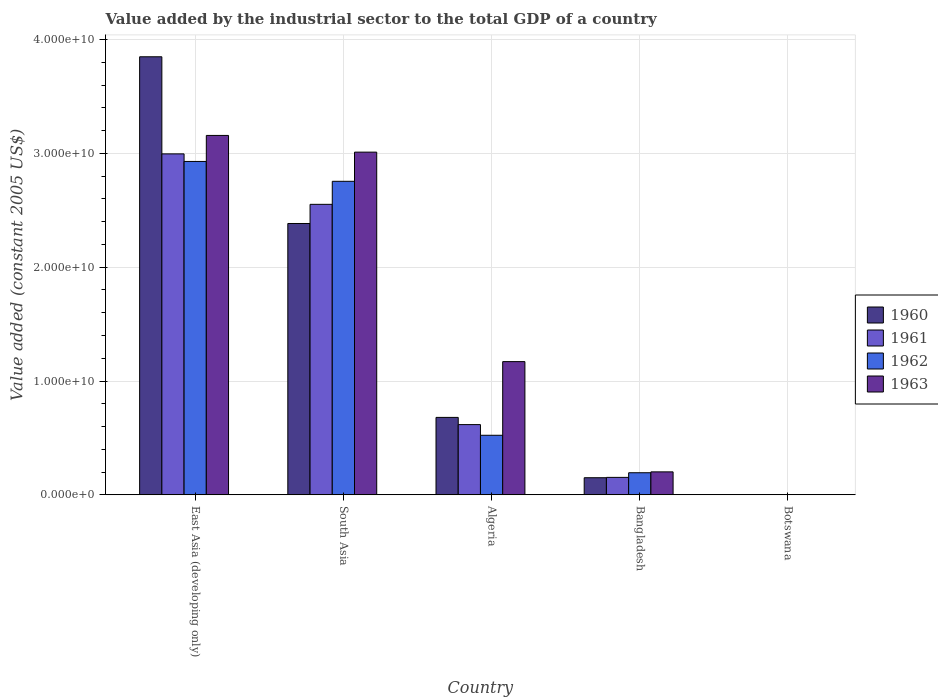How many groups of bars are there?
Your answer should be compact. 5. Are the number of bars per tick equal to the number of legend labels?
Provide a short and direct response. Yes. What is the label of the 2nd group of bars from the left?
Provide a short and direct response. South Asia. In how many cases, is the number of bars for a given country not equal to the number of legend labels?
Make the answer very short. 0. What is the value added by the industrial sector in 1963 in South Asia?
Make the answer very short. 3.01e+1. Across all countries, what is the maximum value added by the industrial sector in 1962?
Offer a very short reply. 2.93e+1. Across all countries, what is the minimum value added by the industrial sector in 1961?
Make the answer very short. 1.92e+07. In which country was the value added by the industrial sector in 1962 maximum?
Keep it short and to the point. East Asia (developing only). In which country was the value added by the industrial sector in 1960 minimum?
Offer a very short reply. Botswana. What is the total value added by the industrial sector in 1962 in the graph?
Offer a terse response. 6.40e+1. What is the difference between the value added by the industrial sector in 1962 in Algeria and that in Bangladesh?
Offer a very short reply. 3.29e+09. What is the difference between the value added by the industrial sector in 1960 in South Asia and the value added by the industrial sector in 1963 in Bangladesh?
Give a very brief answer. 2.18e+1. What is the average value added by the industrial sector in 1961 per country?
Your answer should be compact. 1.26e+1. What is the difference between the value added by the industrial sector of/in 1962 and value added by the industrial sector of/in 1961 in Algeria?
Ensure brevity in your answer.  -9.37e+08. What is the ratio of the value added by the industrial sector in 1962 in Botswana to that in South Asia?
Provide a succinct answer. 0. Is the value added by the industrial sector in 1960 in Botswana less than that in South Asia?
Give a very brief answer. Yes. Is the difference between the value added by the industrial sector in 1962 in Bangladesh and Botswana greater than the difference between the value added by the industrial sector in 1961 in Bangladesh and Botswana?
Give a very brief answer. Yes. What is the difference between the highest and the second highest value added by the industrial sector in 1961?
Your answer should be compact. -2.38e+1. What is the difference between the highest and the lowest value added by the industrial sector in 1960?
Your answer should be compact. 3.85e+1. Is the sum of the value added by the industrial sector in 1962 in Bangladesh and Botswana greater than the maximum value added by the industrial sector in 1963 across all countries?
Offer a terse response. No. Is it the case that in every country, the sum of the value added by the industrial sector in 1961 and value added by the industrial sector in 1960 is greater than the value added by the industrial sector in 1963?
Make the answer very short. Yes. What is the difference between two consecutive major ticks on the Y-axis?
Keep it short and to the point. 1.00e+1. Are the values on the major ticks of Y-axis written in scientific E-notation?
Offer a very short reply. Yes. Does the graph contain any zero values?
Give a very brief answer. No. What is the title of the graph?
Offer a terse response. Value added by the industrial sector to the total GDP of a country. What is the label or title of the Y-axis?
Your answer should be very brief. Value added (constant 2005 US$). What is the Value added (constant 2005 US$) in 1960 in East Asia (developing only)?
Make the answer very short. 3.85e+1. What is the Value added (constant 2005 US$) in 1961 in East Asia (developing only)?
Keep it short and to the point. 3.00e+1. What is the Value added (constant 2005 US$) of 1962 in East Asia (developing only)?
Ensure brevity in your answer.  2.93e+1. What is the Value added (constant 2005 US$) in 1963 in East Asia (developing only)?
Your response must be concise. 3.16e+1. What is the Value added (constant 2005 US$) in 1960 in South Asia?
Your answer should be very brief. 2.38e+1. What is the Value added (constant 2005 US$) of 1961 in South Asia?
Your answer should be compact. 2.55e+1. What is the Value added (constant 2005 US$) of 1962 in South Asia?
Provide a short and direct response. 2.76e+1. What is the Value added (constant 2005 US$) of 1963 in South Asia?
Keep it short and to the point. 3.01e+1. What is the Value added (constant 2005 US$) of 1960 in Algeria?
Make the answer very short. 6.80e+09. What is the Value added (constant 2005 US$) of 1961 in Algeria?
Your answer should be very brief. 6.17e+09. What is the Value added (constant 2005 US$) in 1962 in Algeria?
Your response must be concise. 5.23e+09. What is the Value added (constant 2005 US$) in 1963 in Algeria?
Provide a succinct answer. 1.17e+1. What is the Value added (constant 2005 US$) of 1960 in Bangladesh?
Make the answer very short. 1.50e+09. What is the Value added (constant 2005 US$) in 1961 in Bangladesh?
Your response must be concise. 1.53e+09. What is the Value added (constant 2005 US$) of 1962 in Bangladesh?
Provide a succinct answer. 1.94e+09. What is the Value added (constant 2005 US$) in 1963 in Bangladesh?
Keep it short and to the point. 2.01e+09. What is the Value added (constant 2005 US$) in 1960 in Botswana?
Your answer should be very brief. 1.96e+07. What is the Value added (constant 2005 US$) in 1961 in Botswana?
Offer a terse response. 1.92e+07. What is the Value added (constant 2005 US$) in 1962 in Botswana?
Your response must be concise. 1.98e+07. What is the Value added (constant 2005 US$) of 1963 in Botswana?
Provide a succinct answer. 1.83e+07. Across all countries, what is the maximum Value added (constant 2005 US$) of 1960?
Offer a very short reply. 3.85e+1. Across all countries, what is the maximum Value added (constant 2005 US$) in 1961?
Offer a terse response. 3.00e+1. Across all countries, what is the maximum Value added (constant 2005 US$) of 1962?
Provide a short and direct response. 2.93e+1. Across all countries, what is the maximum Value added (constant 2005 US$) of 1963?
Provide a succinct answer. 3.16e+1. Across all countries, what is the minimum Value added (constant 2005 US$) in 1960?
Make the answer very short. 1.96e+07. Across all countries, what is the minimum Value added (constant 2005 US$) in 1961?
Provide a succinct answer. 1.92e+07. Across all countries, what is the minimum Value added (constant 2005 US$) of 1962?
Make the answer very short. 1.98e+07. Across all countries, what is the minimum Value added (constant 2005 US$) in 1963?
Provide a short and direct response. 1.83e+07. What is the total Value added (constant 2005 US$) of 1960 in the graph?
Provide a succinct answer. 7.07e+1. What is the total Value added (constant 2005 US$) of 1961 in the graph?
Provide a succinct answer. 6.32e+1. What is the total Value added (constant 2005 US$) in 1962 in the graph?
Make the answer very short. 6.40e+1. What is the total Value added (constant 2005 US$) of 1963 in the graph?
Provide a short and direct response. 7.54e+1. What is the difference between the Value added (constant 2005 US$) of 1960 in East Asia (developing only) and that in South Asia?
Ensure brevity in your answer.  1.47e+1. What is the difference between the Value added (constant 2005 US$) of 1961 in East Asia (developing only) and that in South Asia?
Provide a short and direct response. 4.43e+09. What is the difference between the Value added (constant 2005 US$) of 1962 in East Asia (developing only) and that in South Asia?
Make the answer very short. 1.74e+09. What is the difference between the Value added (constant 2005 US$) in 1963 in East Asia (developing only) and that in South Asia?
Your answer should be compact. 1.47e+09. What is the difference between the Value added (constant 2005 US$) of 1960 in East Asia (developing only) and that in Algeria?
Offer a very short reply. 3.17e+1. What is the difference between the Value added (constant 2005 US$) of 1961 in East Asia (developing only) and that in Algeria?
Provide a short and direct response. 2.38e+1. What is the difference between the Value added (constant 2005 US$) of 1962 in East Asia (developing only) and that in Algeria?
Your answer should be compact. 2.41e+1. What is the difference between the Value added (constant 2005 US$) of 1963 in East Asia (developing only) and that in Algeria?
Your response must be concise. 1.99e+1. What is the difference between the Value added (constant 2005 US$) of 1960 in East Asia (developing only) and that in Bangladesh?
Give a very brief answer. 3.70e+1. What is the difference between the Value added (constant 2005 US$) of 1961 in East Asia (developing only) and that in Bangladesh?
Offer a very short reply. 2.84e+1. What is the difference between the Value added (constant 2005 US$) of 1962 in East Asia (developing only) and that in Bangladesh?
Offer a terse response. 2.74e+1. What is the difference between the Value added (constant 2005 US$) in 1963 in East Asia (developing only) and that in Bangladesh?
Provide a short and direct response. 2.96e+1. What is the difference between the Value added (constant 2005 US$) of 1960 in East Asia (developing only) and that in Botswana?
Offer a terse response. 3.85e+1. What is the difference between the Value added (constant 2005 US$) of 1961 in East Asia (developing only) and that in Botswana?
Offer a terse response. 2.99e+1. What is the difference between the Value added (constant 2005 US$) in 1962 in East Asia (developing only) and that in Botswana?
Offer a terse response. 2.93e+1. What is the difference between the Value added (constant 2005 US$) of 1963 in East Asia (developing only) and that in Botswana?
Your response must be concise. 3.16e+1. What is the difference between the Value added (constant 2005 US$) of 1960 in South Asia and that in Algeria?
Your answer should be very brief. 1.70e+1. What is the difference between the Value added (constant 2005 US$) of 1961 in South Asia and that in Algeria?
Your response must be concise. 1.94e+1. What is the difference between the Value added (constant 2005 US$) of 1962 in South Asia and that in Algeria?
Provide a succinct answer. 2.23e+1. What is the difference between the Value added (constant 2005 US$) in 1963 in South Asia and that in Algeria?
Provide a short and direct response. 1.84e+1. What is the difference between the Value added (constant 2005 US$) of 1960 in South Asia and that in Bangladesh?
Give a very brief answer. 2.23e+1. What is the difference between the Value added (constant 2005 US$) of 1961 in South Asia and that in Bangladesh?
Keep it short and to the point. 2.40e+1. What is the difference between the Value added (constant 2005 US$) in 1962 in South Asia and that in Bangladesh?
Provide a succinct answer. 2.56e+1. What is the difference between the Value added (constant 2005 US$) of 1963 in South Asia and that in Bangladesh?
Provide a short and direct response. 2.81e+1. What is the difference between the Value added (constant 2005 US$) of 1960 in South Asia and that in Botswana?
Give a very brief answer. 2.38e+1. What is the difference between the Value added (constant 2005 US$) in 1961 in South Asia and that in Botswana?
Your answer should be very brief. 2.55e+1. What is the difference between the Value added (constant 2005 US$) of 1962 in South Asia and that in Botswana?
Your response must be concise. 2.75e+1. What is the difference between the Value added (constant 2005 US$) of 1963 in South Asia and that in Botswana?
Your response must be concise. 3.01e+1. What is the difference between the Value added (constant 2005 US$) in 1960 in Algeria and that in Bangladesh?
Your answer should be very brief. 5.30e+09. What is the difference between the Value added (constant 2005 US$) in 1961 in Algeria and that in Bangladesh?
Provide a succinct answer. 4.64e+09. What is the difference between the Value added (constant 2005 US$) in 1962 in Algeria and that in Bangladesh?
Keep it short and to the point. 3.29e+09. What is the difference between the Value added (constant 2005 US$) of 1963 in Algeria and that in Bangladesh?
Give a very brief answer. 9.69e+09. What is the difference between the Value added (constant 2005 US$) of 1960 in Algeria and that in Botswana?
Offer a very short reply. 6.78e+09. What is the difference between the Value added (constant 2005 US$) in 1961 in Algeria and that in Botswana?
Offer a very short reply. 6.15e+09. What is the difference between the Value added (constant 2005 US$) in 1962 in Algeria and that in Botswana?
Offer a very short reply. 5.21e+09. What is the difference between the Value added (constant 2005 US$) of 1963 in Algeria and that in Botswana?
Your answer should be very brief. 1.17e+1. What is the difference between the Value added (constant 2005 US$) of 1960 in Bangladesh and that in Botswana?
Ensure brevity in your answer.  1.48e+09. What is the difference between the Value added (constant 2005 US$) in 1961 in Bangladesh and that in Botswana?
Ensure brevity in your answer.  1.51e+09. What is the difference between the Value added (constant 2005 US$) in 1962 in Bangladesh and that in Botswana?
Your response must be concise. 1.92e+09. What is the difference between the Value added (constant 2005 US$) of 1963 in Bangladesh and that in Botswana?
Your answer should be compact. 2.00e+09. What is the difference between the Value added (constant 2005 US$) in 1960 in East Asia (developing only) and the Value added (constant 2005 US$) in 1961 in South Asia?
Your answer should be compact. 1.30e+1. What is the difference between the Value added (constant 2005 US$) of 1960 in East Asia (developing only) and the Value added (constant 2005 US$) of 1962 in South Asia?
Provide a short and direct response. 1.09e+1. What is the difference between the Value added (constant 2005 US$) in 1960 in East Asia (developing only) and the Value added (constant 2005 US$) in 1963 in South Asia?
Ensure brevity in your answer.  8.38e+09. What is the difference between the Value added (constant 2005 US$) of 1961 in East Asia (developing only) and the Value added (constant 2005 US$) of 1962 in South Asia?
Your response must be concise. 2.41e+09. What is the difference between the Value added (constant 2005 US$) in 1961 in East Asia (developing only) and the Value added (constant 2005 US$) in 1963 in South Asia?
Your answer should be compact. -1.54e+08. What is the difference between the Value added (constant 2005 US$) of 1962 in East Asia (developing only) and the Value added (constant 2005 US$) of 1963 in South Asia?
Ensure brevity in your answer.  -8.18e+08. What is the difference between the Value added (constant 2005 US$) of 1960 in East Asia (developing only) and the Value added (constant 2005 US$) of 1961 in Algeria?
Offer a very short reply. 3.23e+1. What is the difference between the Value added (constant 2005 US$) of 1960 in East Asia (developing only) and the Value added (constant 2005 US$) of 1962 in Algeria?
Keep it short and to the point. 3.33e+1. What is the difference between the Value added (constant 2005 US$) in 1960 in East Asia (developing only) and the Value added (constant 2005 US$) in 1963 in Algeria?
Your response must be concise. 2.68e+1. What is the difference between the Value added (constant 2005 US$) in 1961 in East Asia (developing only) and the Value added (constant 2005 US$) in 1962 in Algeria?
Provide a short and direct response. 2.47e+1. What is the difference between the Value added (constant 2005 US$) in 1961 in East Asia (developing only) and the Value added (constant 2005 US$) in 1963 in Algeria?
Make the answer very short. 1.83e+1. What is the difference between the Value added (constant 2005 US$) of 1962 in East Asia (developing only) and the Value added (constant 2005 US$) of 1963 in Algeria?
Keep it short and to the point. 1.76e+1. What is the difference between the Value added (constant 2005 US$) in 1960 in East Asia (developing only) and the Value added (constant 2005 US$) in 1961 in Bangladesh?
Your answer should be very brief. 3.70e+1. What is the difference between the Value added (constant 2005 US$) of 1960 in East Asia (developing only) and the Value added (constant 2005 US$) of 1962 in Bangladesh?
Ensure brevity in your answer.  3.66e+1. What is the difference between the Value added (constant 2005 US$) in 1960 in East Asia (developing only) and the Value added (constant 2005 US$) in 1963 in Bangladesh?
Offer a terse response. 3.65e+1. What is the difference between the Value added (constant 2005 US$) of 1961 in East Asia (developing only) and the Value added (constant 2005 US$) of 1962 in Bangladesh?
Give a very brief answer. 2.80e+1. What is the difference between the Value added (constant 2005 US$) of 1961 in East Asia (developing only) and the Value added (constant 2005 US$) of 1963 in Bangladesh?
Give a very brief answer. 2.79e+1. What is the difference between the Value added (constant 2005 US$) of 1962 in East Asia (developing only) and the Value added (constant 2005 US$) of 1963 in Bangladesh?
Offer a very short reply. 2.73e+1. What is the difference between the Value added (constant 2005 US$) of 1960 in East Asia (developing only) and the Value added (constant 2005 US$) of 1961 in Botswana?
Give a very brief answer. 3.85e+1. What is the difference between the Value added (constant 2005 US$) in 1960 in East Asia (developing only) and the Value added (constant 2005 US$) in 1962 in Botswana?
Your response must be concise. 3.85e+1. What is the difference between the Value added (constant 2005 US$) in 1960 in East Asia (developing only) and the Value added (constant 2005 US$) in 1963 in Botswana?
Keep it short and to the point. 3.85e+1. What is the difference between the Value added (constant 2005 US$) in 1961 in East Asia (developing only) and the Value added (constant 2005 US$) in 1962 in Botswana?
Offer a very short reply. 2.99e+1. What is the difference between the Value added (constant 2005 US$) in 1961 in East Asia (developing only) and the Value added (constant 2005 US$) in 1963 in Botswana?
Give a very brief answer. 2.99e+1. What is the difference between the Value added (constant 2005 US$) of 1962 in East Asia (developing only) and the Value added (constant 2005 US$) of 1963 in Botswana?
Provide a short and direct response. 2.93e+1. What is the difference between the Value added (constant 2005 US$) in 1960 in South Asia and the Value added (constant 2005 US$) in 1961 in Algeria?
Ensure brevity in your answer.  1.77e+1. What is the difference between the Value added (constant 2005 US$) of 1960 in South Asia and the Value added (constant 2005 US$) of 1962 in Algeria?
Offer a very short reply. 1.86e+1. What is the difference between the Value added (constant 2005 US$) of 1960 in South Asia and the Value added (constant 2005 US$) of 1963 in Algeria?
Make the answer very short. 1.21e+1. What is the difference between the Value added (constant 2005 US$) in 1961 in South Asia and the Value added (constant 2005 US$) in 1962 in Algeria?
Keep it short and to the point. 2.03e+1. What is the difference between the Value added (constant 2005 US$) of 1961 in South Asia and the Value added (constant 2005 US$) of 1963 in Algeria?
Your response must be concise. 1.38e+1. What is the difference between the Value added (constant 2005 US$) in 1962 in South Asia and the Value added (constant 2005 US$) in 1963 in Algeria?
Offer a terse response. 1.58e+1. What is the difference between the Value added (constant 2005 US$) in 1960 in South Asia and the Value added (constant 2005 US$) in 1961 in Bangladesh?
Your answer should be compact. 2.23e+1. What is the difference between the Value added (constant 2005 US$) in 1960 in South Asia and the Value added (constant 2005 US$) in 1962 in Bangladesh?
Your response must be concise. 2.19e+1. What is the difference between the Value added (constant 2005 US$) in 1960 in South Asia and the Value added (constant 2005 US$) in 1963 in Bangladesh?
Ensure brevity in your answer.  2.18e+1. What is the difference between the Value added (constant 2005 US$) in 1961 in South Asia and the Value added (constant 2005 US$) in 1962 in Bangladesh?
Your answer should be very brief. 2.36e+1. What is the difference between the Value added (constant 2005 US$) in 1961 in South Asia and the Value added (constant 2005 US$) in 1963 in Bangladesh?
Give a very brief answer. 2.35e+1. What is the difference between the Value added (constant 2005 US$) in 1962 in South Asia and the Value added (constant 2005 US$) in 1963 in Bangladesh?
Keep it short and to the point. 2.55e+1. What is the difference between the Value added (constant 2005 US$) in 1960 in South Asia and the Value added (constant 2005 US$) in 1961 in Botswana?
Provide a succinct answer. 2.38e+1. What is the difference between the Value added (constant 2005 US$) of 1960 in South Asia and the Value added (constant 2005 US$) of 1962 in Botswana?
Ensure brevity in your answer.  2.38e+1. What is the difference between the Value added (constant 2005 US$) in 1960 in South Asia and the Value added (constant 2005 US$) in 1963 in Botswana?
Provide a short and direct response. 2.38e+1. What is the difference between the Value added (constant 2005 US$) in 1961 in South Asia and the Value added (constant 2005 US$) in 1962 in Botswana?
Keep it short and to the point. 2.55e+1. What is the difference between the Value added (constant 2005 US$) of 1961 in South Asia and the Value added (constant 2005 US$) of 1963 in Botswana?
Provide a succinct answer. 2.55e+1. What is the difference between the Value added (constant 2005 US$) in 1962 in South Asia and the Value added (constant 2005 US$) in 1963 in Botswana?
Your answer should be very brief. 2.75e+1. What is the difference between the Value added (constant 2005 US$) of 1960 in Algeria and the Value added (constant 2005 US$) of 1961 in Bangladesh?
Keep it short and to the point. 5.27e+09. What is the difference between the Value added (constant 2005 US$) of 1960 in Algeria and the Value added (constant 2005 US$) of 1962 in Bangladesh?
Offer a terse response. 4.86e+09. What is the difference between the Value added (constant 2005 US$) in 1960 in Algeria and the Value added (constant 2005 US$) in 1963 in Bangladesh?
Your answer should be very brief. 4.79e+09. What is the difference between the Value added (constant 2005 US$) in 1961 in Algeria and the Value added (constant 2005 US$) in 1962 in Bangladesh?
Your response must be concise. 4.23e+09. What is the difference between the Value added (constant 2005 US$) in 1961 in Algeria and the Value added (constant 2005 US$) in 1963 in Bangladesh?
Ensure brevity in your answer.  4.15e+09. What is the difference between the Value added (constant 2005 US$) in 1962 in Algeria and the Value added (constant 2005 US$) in 1963 in Bangladesh?
Keep it short and to the point. 3.22e+09. What is the difference between the Value added (constant 2005 US$) in 1960 in Algeria and the Value added (constant 2005 US$) in 1961 in Botswana?
Keep it short and to the point. 6.78e+09. What is the difference between the Value added (constant 2005 US$) in 1960 in Algeria and the Value added (constant 2005 US$) in 1962 in Botswana?
Keep it short and to the point. 6.78e+09. What is the difference between the Value added (constant 2005 US$) in 1960 in Algeria and the Value added (constant 2005 US$) in 1963 in Botswana?
Your answer should be very brief. 6.78e+09. What is the difference between the Value added (constant 2005 US$) of 1961 in Algeria and the Value added (constant 2005 US$) of 1962 in Botswana?
Offer a very short reply. 6.15e+09. What is the difference between the Value added (constant 2005 US$) of 1961 in Algeria and the Value added (constant 2005 US$) of 1963 in Botswana?
Provide a succinct answer. 6.15e+09. What is the difference between the Value added (constant 2005 US$) in 1962 in Algeria and the Value added (constant 2005 US$) in 1963 in Botswana?
Give a very brief answer. 5.21e+09. What is the difference between the Value added (constant 2005 US$) in 1960 in Bangladesh and the Value added (constant 2005 US$) in 1961 in Botswana?
Ensure brevity in your answer.  1.48e+09. What is the difference between the Value added (constant 2005 US$) in 1960 in Bangladesh and the Value added (constant 2005 US$) in 1962 in Botswana?
Your response must be concise. 1.48e+09. What is the difference between the Value added (constant 2005 US$) of 1960 in Bangladesh and the Value added (constant 2005 US$) of 1963 in Botswana?
Ensure brevity in your answer.  1.48e+09. What is the difference between the Value added (constant 2005 US$) in 1961 in Bangladesh and the Value added (constant 2005 US$) in 1962 in Botswana?
Provide a short and direct response. 1.51e+09. What is the difference between the Value added (constant 2005 US$) of 1961 in Bangladesh and the Value added (constant 2005 US$) of 1963 in Botswana?
Provide a short and direct response. 1.51e+09. What is the difference between the Value added (constant 2005 US$) in 1962 in Bangladesh and the Value added (constant 2005 US$) in 1963 in Botswana?
Ensure brevity in your answer.  1.92e+09. What is the average Value added (constant 2005 US$) in 1960 per country?
Offer a terse response. 1.41e+1. What is the average Value added (constant 2005 US$) of 1961 per country?
Offer a very short reply. 1.26e+1. What is the average Value added (constant 2005 US$) in 1962 per country?
Your answer should be very brief. 1.28e+1. What is the average Value added (constant 2005 US$) in 1963 per country?
Provide a succinct answer. 1.51e+1. What is the difference between the Value added (constant 2005 US$) in 1960 and Value added (constant 2005 US$) in 1961 in East Asia (developing only)?
Keep it short and to the point. 8.53e+09. What is the difference between the Value added (constant 2005 US$) of 1960 and Value added (constant 2005 US$) of 1962 in East Asia (developing only)?
Ensure brevity in your answer.  9.20e+09. What is the difference between the Value added (constant 2005 US$) of 1960 and Value added (constant 2005 US$) of 1963 in East Asia (developing only)?
Keep it short and to the point. 6.91e+09. What is the difference between the Value added (constant 2005 US$) in 1961 and Value added (constant 2005 US$) in 1962 in East Asia (developing only)?
Offer a very short reply. 6.65e+08. What is the difference between the Value added (constant 2005 US$) of 1961 and Value added (constant 2005 US$) of 1963 in East Asia (developing only)?
Your answer should be compact. -1.62e+09. What is the difference between the Value added (constant 2005 US$) in 1962 and Value added (constant 2005 US$) in 1963 in East Asia (developing only)?
Your response must be concise. -2.29e+09. What is the difference between the Value added (constant 2005 US$) in 1960 and Value added (constant 2005 US$) in 1961 in South Asia?
Make the answer very short. -1.68e+09. What is the difference between the Value added (constant 2005 US$) in 1960 and Value added (constant 2005 US$) in 1962 in South Asia?
Keep it short and to the point. -3.71e+09. What is the difference between the Value added (constant 2005 US$) of 1960 and Value added (constant 2005 US$) of 1963 in South Asia?
Provide a succinct answer. -6.27e+09. What is the difference between the Value added (constant 2005 US$) of 1961 and Value added (constant 2005 US$) of 1962 in South Asia?
Give a very brief answer. -2.02e+09. What is the difference between the Value added (constant 2005 US$) of 1961 and Value added (constant 2005 US$) of 1963 in South Asia?
Offer a terse response. -4.59e+09. What is the difference between the Value added (constant 2005 US$) of 1962 and Value added (constant 2005 US$) of 1963 in South Asia?
Provide a short and direct response. -2.56e+09. What is the difference between the Value added (constant 2005 US$) of 1960 and Value added (constant 2005 US$) of 1961 in Algeria?
Your answer should be very brief. 6.34e+08. What is the difference between the Value added (constant 2005 US$) in 1960 and Value added (constant 2005 US$) in 1962 in Algeria?
Make the answer very short. 1.57e+09. What is the difference between the Value added (constant 2005 US$) in 1960 and Value added (constant 2005 US$) in 1963 in Algeria?
Keep it short and to the point. -4.90e+09. What is the difference between the Value added (constant 2005 US$) in 1961 and Value added (constant 2005 US$) in 1962 in Algeria?
Provide a succinct answer. 9.37e+08. What is the difference between the Value added (constant 2005 US$) in 1961 and Value added (constant 2005 US$) in 1963 in Algeria?
Your answer should be compact. -5.54e+09. What is the difference between the Value added (constant 2005 US$) of 1962 and Value added (constant 2005 US$) of 1963 in Algeria?
Your response must be concise. -6.47e+09. What is the difference between the Value added (constant 2005 US$) in 1960 and Value added (constant 2005 US$) in 1961 in Bangladesh?
Give a very brief answer. -3.05e+07. What is the difference between the Value added (constant 2005 US$) of 1960 and Value added (constant 2005 US$) of 1962 in Bangladesh?
Your answer should be very brief. -4.38e+08. What is the difference between the Value added (constant 2005 US$) of 1960 and Value added (constant 2005 US$) of 1963 in Bangladesh?
Ensure brevity in your answer.  -5.14e+08. What is the difference between the Value added (constant 2005 US$) in 1961 and Value added (constant 2005 US$) in 1962 in Bangladesh?
Make the answer very short. -4.08e+08. What is the difference between the Value added (constant 2005 US$) in 1961 and Value added (constant 2005 US$) in 1963 in Bangladesh?
Your answer should be very brief. -4.84e+08. What is the difference between the Value added (constant 2005 US$) in 1962 and Value added (constant 2005 US$) in 1963 in Bangladesh?
Your answer should be very brief. -7.60e+07. What is the difference between the Value added (constant 2005 US$) in 1960 and Value added (constant 2005 US$) in 1961 in Botswana?
Keep it short and to the point. 4.24e+05. What is the difference between the Value added (constant 2005 US$) in 1960 and Value added (constant 2005 US$) in 1962 in Botswana?
Offer a terse response. -2.12e+05. What is the difference between the Value added (constant 2005 US$) in 1960 and Value added (constant 2005 US$) in 1963 in Botswana?
Your answer should be very brief. 1.27e+06. What is the difference between the Value added (constant 2005 US$) in 1961 and Value added (constant 2005 US$) in 1962 in Botswana?
Provide a succinct answer. -6.36e+05. What is the difference between the Value added (constant 2005 US$) in 1961 and Value added (constant 2005 US$) in 1963 in Botswana?
Give a very brief answer. 8.48e+05. What is the difference between the Value added (constant 2005 US$) of 1962 and Value added (constant 2005 US$) of 1963 in Botswana?
Your response must be concise. 1.48e+06. What is the ratio of the Value added (constant 2005 US$) of 1960 in East Asia (developing only) to that in South Asia?
Offer a very short reply. 1.61. What is the ratio of the Value added (constant 2005 US$) in 1961 in East Asia (developing only) to that in South Asia?
Your answer should be compact. 1.17. What is the ratio of the Value added (constant 2005 US$) of 1962 in East Asia (developing only) to that in South Asia?
Ensure brevity in your answer.  1.06. What is the ratio of the Value added (constant 2005 US$) in 1963 in East Asia (developing only) to that in South Asia?
Your answer should be very brief. 1.05. What is the ratio of the Value added (constant 2005 US$) in 1960 in East Asia (developing only) to that in Algeria?
Your answer should be very brief. 5.66. What is the ratio of the Value added (constant 2005 US$) in 1961 in East Asia (developing only) to that in Algeria?
Keep it short and to the point. 4.86. What is the ratio of the Value added (constant 2005 US$) of 1962 in East Asia (developing only) to that in Algeria?
Provide a succinct answer. 5.6. What is the ratio of the Value added (constant 2005 US$) in 1963 in East Asia (developing only) to that in Algeria?
Offer a terse response. 2.7. What is the ratio of the Value added (constant 2005 US$) of 1960 in East Asia (developing only) to that in Bangladesh?
Give a very brief answer. 25.66. What is the ratio of the Value added (constant 2005 US$) in 1961 in East Asia (developing only) to that in Bangladesh?
Ensure brevity in your answer.  19.57. What is the ratio of the Value added (constant 2005 US$) in 1962 in East Asia (developing only) to that in Bangladesh?
Provide a succinct answer. 15.11. What is the ratio of the Value added (constant 2005 US$) in 1963 in East Asia (developing only) to that in Bangladesh?
Ensure brevity in your answer.  15.68. What is the ratio of the Value added (constant 2005 US$) of 1960 in East Asia (developing only) to that in Botswana?
Provide a succinct answer. 1962.41. What is the ratio of the Value added (constant 2005 US$) in 1961 in East Asia (developing only) to that in Botswana?
Keep it short and to the point. 1561.12. What is the ratio of the Value added (constant 2005 US$) in 1962 in East Asia (developing only) to that in Botswana?
Offer a terse response. 1477.51. What is the ratio of the Value added (constant 2005 US$) of 1963 in East Asia (developing only) to that in Botswana?
Ensure brevity in your answer.  1721.68. What is the ratio of the Value added (constant 2005 US$) of 1960 in South Asia to that in Algeria?
Your answer should be very brief. 3.5. What is the ratio of the Value added (constant 2005 US$) in 1961 in South Asia to that in Algeria?
Keep it short and to the point. 4.14. What is the ratio of the Value added (constant 2005 US$) of 1962 in South Asia to that in Algeria?
Give a very brief answer. 5.27. What is the ratio of the Value added (constant 2005 US$) in 1963 in South Asia to that in Algeria?
Offer a terse response. 2.57. What is the ratio of the Value added (constant 2005 US$) in 1960 in South Asia to that in Bangladesh?
Give a very brief answer. 15.89. What is the ratio of the Value added (constant 2005 US$) in 1961 in South Asia to that in Bangladesh?
Offer a very short reply. 16.68. What is the ratio of the Value added (constant 2005 US$) of 1962 in South Asia to that in Bangladesh?
Make the answer very short. 14.21. What is the ratio of the Value added (constant 2005 US$) of 1963 in South Asia to that in Bangladesh?
Provide a short and direct response. 14.95. What is the ratio of the Value added (constant 2005 US$) of 1960 in South Asia to that in Botswana?
Make the answer very short. 1215.49. What is the ratio of the Value added (constant 2005 US$) in 1961 in South Asia to that in Botswana?
Offer a very short reply. 1330.08. What is the ratio of the Value added (constant 2005 US$) in 1962 in South Asia to that in Botswana?
Provide a succinct answer. 1389.51. What is the ratio of the Value added (constant 2005 US$) in 1963 in South Asia to that in Botswana?
Your response must be concise. 1641.69. What is the ratio of the Value added (constant 2005 US$) of 1960 in Algeria to that in Bangladesh?
Offer a terse response. 4.53. What is the ratio of the Value added (constant 2005 US$) of 1961 in Algeria to that in Bangladesh?
Keep it short and to the point. 4.03. What is the ratio of the Value added (constant 2005 US$) in 1962 in Algeria to that in Bangladesh?
Your answer should be compact. 2.7. What is the ratio of the Value added (constant 2005 US$) in 1963 in Algeria to that in Bangladesh?
Provide a short and direct response. 5.81. What is the ratio of the Value added (constant 2005 US$) in 1960 in Algeria to that in Botswana?
Give a very brief answer. 346.79. What is the ratio of the Value added (constant 2005 US$) of 1961 in Algeria to that in Botswana?
Your answer should be very brief. 321.41. What is the ratio of the Value added (constant 2005 US$) in 1962 in Algeria to that in Botswana?
Your answer should be compact. 263.85. What is the ratio of the Value added (constant 2005 US$) of 1963 in Algeria to that in Botswana?
Provide a short and direct response. 638.08. What is the ratio of the Value added (constant 2005 US$) of 1960 in Bangladesh to that in Botswana?
Give a very brief answer. 76.48. What is the ratio of the Value added (constant 2005 US$) in 1961 in Bangladesh to that in Botswana?
Give a very brief answer. 79.76. What is the ratio of the Value added (constant 2005 US$) in 1962 in Bangladesh to that in Botswana?
Give a very brief answer. 97.78. What is the ratio of the Value added (constant 2005 US$) of 1963 in Bangladesh to that in Botswana?
Ensure brevity in your answer.  109.83. What is the difference between the highest and the second highest Value added (constant 2005 US$) of 1960?
Make the answer very short. 1.47e+1. What is the difference between the highest and the second highest Value added (constant 2005 US$) of 1961?
Your answer should be compact. 4.43e+09. What is the difference between the highest and the second highest Value added (constant 2005 US$) of 1962?
Your answer should be compact. 1.74e+09. What is the difference between the highest and the second highest Value added (constant 2005 US$) of 1963?
Make the answer very short. 1.47e+09. What is the difference between the highest and the lowest Value added (constant 2005 US$) in 1960?
Keep it short and to the point. 3.85e+1. What is the difference between the highest and the lowest Value added (constant 2005 US$) of 1961?
Your answer should be very brief. 2.99e+1. What is the difference between the highest and the lowest Value added (constant 2005 US$) of 1962?
Ensure brevity in your answer.  2.93e+1. What is the difference between the highest and the lowest Value added (constant 2005 US$) in 1963?
Your answer should be very brief. 3.16e+1. 